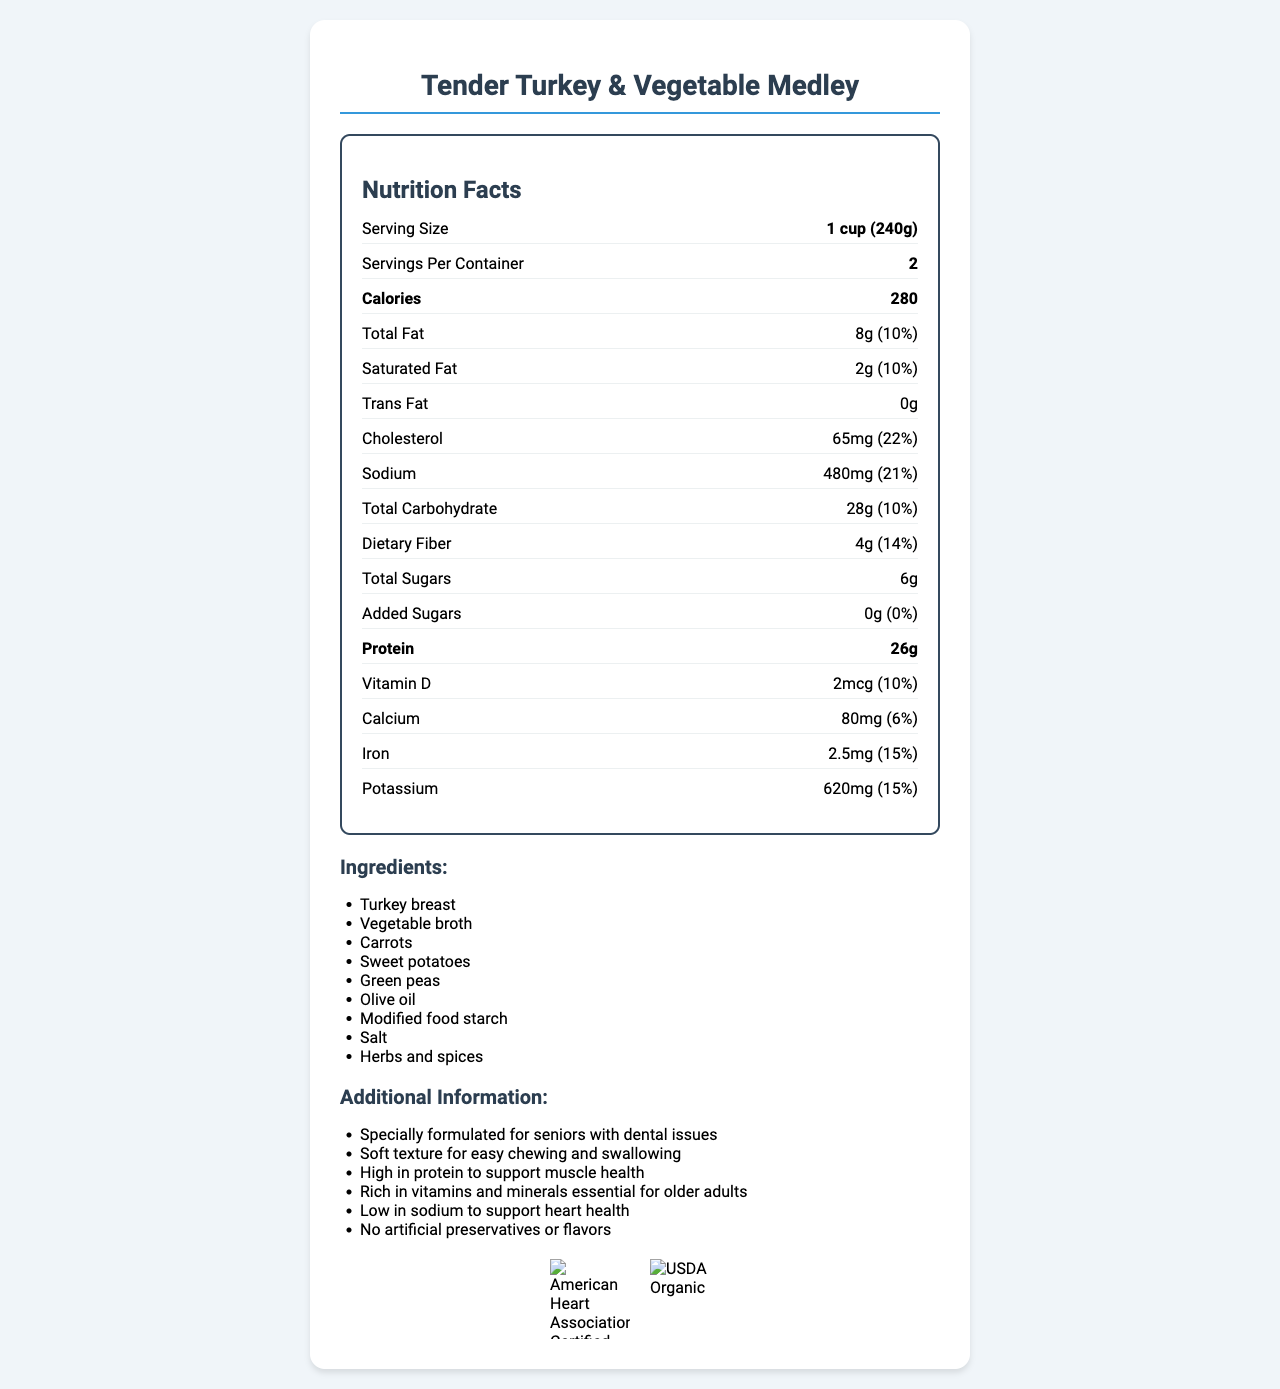who is the manufacturer of the product? The manufacturer information is listed towards the end of the document.
Answer: Golden Years Nutrition, Inc. what is the serving size for "Tender Turkey & Vegetable Medley"? The serving size is mentioned at the top of the nutrition facts section.
Answer: 1 cup (240g) what percentage of the daily value for protein does one serving provide? The document lists the protein amount as 26g but does not provide a daily value percentage.
Answer: The document does not specify the percentage of daily value for protein. how many calories are there in one serving? The calorie information is found in the nutrition facts section and falls under "Calories".
Answer: 280 calories what is the main ingredient in "Tender Turkey & Vegetable Medley"? The ingredients list starts with "Turkey breast", which is typically the main ingredient.
Answer: Turkey breast is this product suitable for people with common food allergies? The document states that the product contains no common allergens.
Answer: Yes which of these minerals is most abundant in one serving: calcium, iron, or potassium? A. Calcium B. Iron C. Potassium The potassium content is 620mg, which is higher than calcium (80mg) and iron (2.5mg).
Answer: C. Potassium what is the daily value percentage of sodium in one serving? A. 10% B. 21% C. 22% The sodium content is 480mg, which corresponds to 21% of the daily value.
Answer: B. 21% how many servings are there per container? The document specifies "Servings Per Container: 2" in the nutrition facts section.
Answer: 2 does this product contain any artificial preservatives or flavors? The document states that there are no artificial preservatives or flavors.
Answer: No how should this product be stored after opening? The storage instructions clearly state to keep the product refrigerated and to use it within 3 days of opening.
Answer: Keep refrigerated. Use within 3 days of opening. is the amount of added sugars in this product high? The amount of added sugars is 0g, which is 0% of the daily value.
Answer: No how should this product be prepared? The preparation instructions specify to heat the product in the microwave for 2-3 minutes or until it reaches an internal temperature of 165°F.
Answer: Heat in microwave for 2-3 minutes or until internal temperature reaches 165°F (74°C) which organization has certified this product? The document shows that the product is certified by the American Heart Association and USDA Organic with respective logos.
Answer: American Heart Association and USDA Organic will this product support muscle health? The document mentions that the product is high in protein to support muscle health.
Answer: Yes does this product have a high or low fat content? The total fat content is 8g, which is 10% of the daily value, generally considered low.
Answer: Low what are the additional features of this product that make it suitable for elderly residents? This additional information is listed towards the end of the document as a bulleted list.
Answer: Specially formulated for seniors with dental issues, soft texture for easy chewing and swallowing, high in protein to support muscle health, rich in vitamins and minerals essential for older adults, low in sodium to support heart health, no artificial preservatives or flavors summarize the main idea of the document. The summary encapsulates the core aspects of the nutrition facts, additional information, and certifications for the product.
Answer: The document provides detailed nutritional information and features of the "Tender Turkey & Vegetable Medley", a meal designed for elderly residents with dental issues. It highlights protein content, soft texture, and various health benefits while detailing ingredient composition and storage/preparation instructions. The product is certified by the American Heart Association and USDA Organic. what type of dietary fiber is present in the product? The document only lists the total dietary fiber content but does not specify the type of dietary fiber.
Answer: Not enough information 